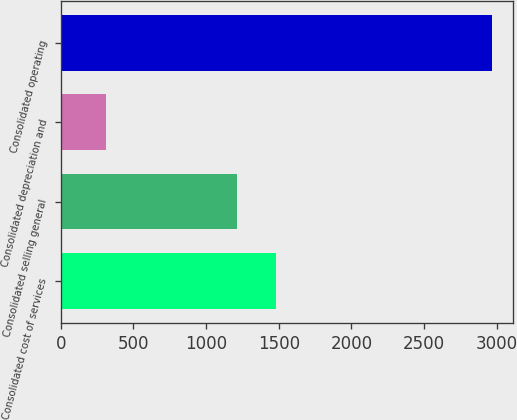Convert chart. <chart><loc_0><loc_0><loc_500><loc_500><bar_chart><fcel>Consolidated cost of services<fcel>Consolidated selling general<fcel>Consolidated depreciation and<fcel>Consolidated operating<nl><fcel>1478.67<fcel>1213.3<fcel>310.4<fcel>2964.1<nl></chart> 